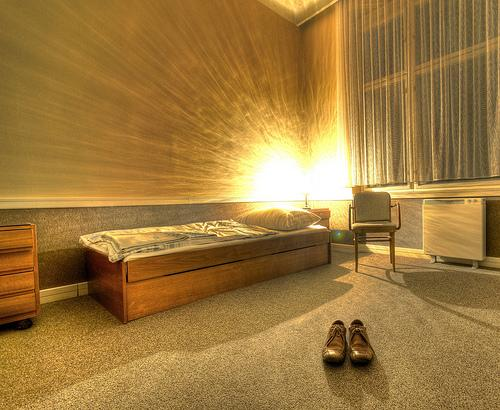List 3 objects which are made from wood that you can find in this image. A wooden bed frame, small wooden dresser, and wooden upholstered chair. In the image, what type of bed is present? There is a wooden bed frame for a single person. How are the walls described in this image and which object is casting shadow on them? The walls are cream colored, and a large shadow is casted on the carpet. Can you describe the look of the carpet on the floor and its color? The carpet is mottled gray and light brown. What is the color and pattern of the pillow on the bed in this image? The pillow on the bed is white and blue. What kind of light is coming into the room and what does it create on the wall? Bright light is coming into the room, creating reflections on the wall. Describe the location of the pair of brown shoes in the context of the room. The pair of brown shoes are sitting in the middle of the floor on the light brown carpet. What are the primary colors of the light in the corner of the room? The light in the corner is bright yellow and orange. Identify the type of furniture that is placed near the window. A chair is near the window. What kind of window furnishing is covering the large window? There are sheer curtains in front of the large window with a closed lace curtain. Is there a red chair near the window? This instruction is misleading because there is a chair near the window, but it is not red. The chair is described as both wooden upholstered chair and simple upholstered chair, the color is not mentioned.  The window has blue curtains, right? The window is described as having drapes, sheer curtains, or curtains - but the color is not mentioned anywhere, making the blue color a misleading attribute.  Find the green dresser on the right side of the room. There is a dresser, but it is described as small wooden, brown chest of drawers, or brown small dresser cabinet - no mention of green. Also, it is located on the left side of the room (X:0, Y:217).  Check if there's a purple pillow on the bed! There is a pillow on the bed, but it is described as white and blue, not purple. Can you see a large potted plant in the corner of the room? There is no mention of any potted plant in the image, making this instruction misleading as well. Look at the double bed in the center of the image. The bed in the image is described as a single bed, a bed with a wooden bed frame, or captains bed, but not as a double bed.  There's a ceiling fan in the middle of the room, right? There is no mention of a ceiling fan in the image, making this instruction completely misleading. Is the radiator painted in yellow? There is a radiator in the image, but no information is given about its color. Assuming it is yellow can be misleading. Is there a colorful carpet covering the entire floor? There is a carpet in the image, but it is described as mottled gray carpet or light brown carpet, not colorful. Also, it appears to be partially covering the floor, not the entire floor. Find me a black pair of shoes on the floor! There are several pairs of shoes in the image, all described as brown or tan. No mention of a black pair of shoes on the floor. 